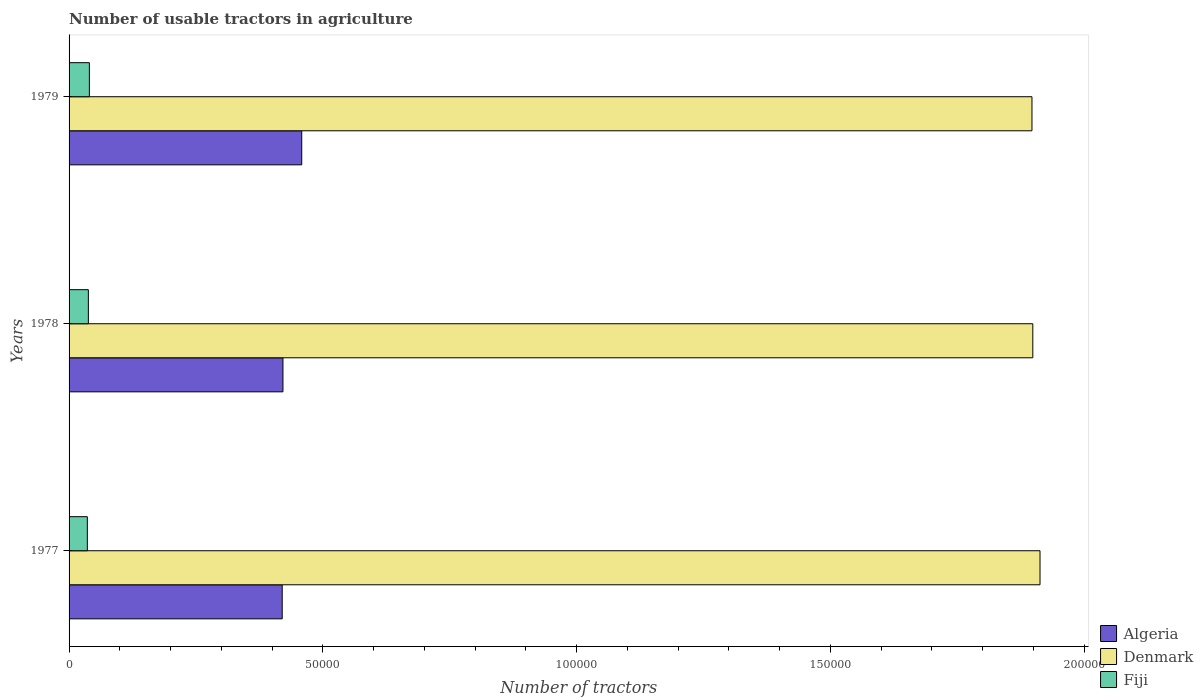How many different coloured bars are there?
Ensure brevity in your answer.  3. Are the number of bars per tick equal to the number of legend labels?
Your answer should be very brief. Yes. How many bars are there on the 1st tick from the bottom?
Offer a terse response. 3. What is the label of the 1st group of bars from the top?
Your response must be concise. 1979. What is the number of usable tractors in agriculture in Fiji in 1977?
Your answer should be compact. 3600. Across all years, what is the maximum number of usable tractors in agriculture in Denmark?
Make the answer very short. 1.91e+05. Across all years, what is the minimum number of usable tractors in agriculture in Fiji?
Your answer should be compact. 3600. What is the total number of usable tractors in agriculture in Algeria in the graph?
Keep it short and to the point. 1.30e+05. What is the difference between the number of usable tractors in agriculture in Denmark in 1977 and that in 1979?
Your response must be concise. 1585. What is the difference between the number of usable tractors in agriculture in Denmark in 1979 and the number of usable tractors in agriculture in Algeria in 1978?
Provide a short and direct response. 1.48e+05. What is the average number of usable tractors in agriculture in Fiji per year?
Your answer should be compact. 3800. In the year 1979, what is the difference between the number of usable tractors in agriculture in Fiji and number of usable tractors in agriculture in Denmark?
Your response must be concise. -1.86e+05. What is the ratio of the number of usable tractors in agriculture in Fiji in 1977 to that in 1978?
Your response must be concise. 0.95. Is the difference between the number of usable tractors in agriculture in Fiji in 1978 and 1979 greater than the difference between the number of usable tractors in agriculture in Denmark in 1978 and 1979?
Your answer should be compact. No. What is the difference between the highest and the second highest number of usable tractors in agriculture in Algeria?
Provide a succinct answer. 3700. What is the difference between the highest and the lowest number of usable tractors in agriculture in Algeria?
Provide a succinct answer. 3847. What does the 3rd bar from the top in 1978 represents?
Offer a terse response. Algeria. What does the 1st bar from the bottom in 1978 represents?
Make the answer very short. Algeria. Is it the case that in every year, the sum of the number of usable tractors in agriculture in Fiji and number of usable tractors in agriculture in Algeria is greater than the number of usable tractors in agriculture in Denmark?
Your answer should be compact. No. Are all the bars in the graph horizontal?
Your response must be concise. Yes. How many years are there in the graph?
Your answer should be compact. 3. What is the difference between two consecutive major ticks on the X-axis?
Your response must be concise. 5.00e+04. Does the graph contain grids?
Make the answer very short. No. How many legend labels are there?
Make the answer very short. 3. How are the legend labels stacked?
Ensure brevity in your answer.  Vertical. What is the title of the graph?
Make the answer very short. Number of usable tractors in agriculture. What is the label or title of the X-axis?
Provide a short and direct response. Number of tractors. What is the label or title of the Y-axis?
Offer a very short reply. Years. What is the Number of tractors of Algeria in 1977?
Give a very brief answer. 4.20e+04. What is the Number of tractors of Denmark in 1977?
Offer a very short reply. 1.91e+05. What is the Number of tractors in Fiji in 1977?
Provide a short and direct response. 3600. What is the Number of tractors in Algeria in 1978?
Provide a short and direct response. 4.21e+04. What is the Number of tractors in Denmark in 1978?
Offer a very short reply. 1.90e+05. What is the Number of tractors in Fiji in 1978?
Keep it short and to the point. 3800. What is the Number of tractors in Algeria in 1979?
Offer a very short reply. 4.58e+04. What is the Number of tractors in Denmark in 1979?
Provide a short and direct response. 1.90e+05. What is the Number of tractors of Fiji in 1979?
Provide a short and direct response. 4000. Across all years, what is the maximum Number of tractors of Algeria?
Your answer should be compact. 4.58e+04. Across all years, what is the maximum Number of tractors in Denmark?
Make the answer very short. 1.91e+05. Across all years, what is the maximum Number of tractors of Fiji?
Offer a very short reply. 4000. Across all years, what is the minimum Number of tractors of Algeria?
Make the answer very short. 4.20e+04. Across all years, what is the minimum Number of tractors of Denmark?
Ensure brevity in your answer.  1.90e+05. Across all years, what is the minimum Number of tractors in Fiji?
Offer a very short reply. 3600. What is the total Number of tractors in Algeria in the graph?
Your answer should be very brief. 1.30e+05. What is the total Number of tractors of Denmark in the graph?
Keep it short and to the point. 5.71e+05. What is the total Number of tractors in Fiji in the graph?
Provide a succinct answer. 1.14e+04. What is the difference between the Number of tractors of Algeria in 1977 and that in 1978?
Make the answer very short. -147. What is the difference between the Number of tractors in Denmark in 1977 and that in 1978?
Offer a very short reply. 1418. What is the difference between the Number of tractors in Fiji in 1977 and that in 1978?
Provide a succinct answer. -200. What is the difference between the Number of tractors of Algeria in 1977 and that in 1979?
Make the answer very short. -3847. What is the difference between the Number of tractors in Denmark in 1977 and that in 1979?
Your answer should be very brief. 1585. What is the difference between the Number of tractors in Fiji in 1977 and that in 1979?
Provide a succinct answer. -400. What is the difference between the Number of tractors in Algeria in 1978 and that in 1979?
Offer a terse response. -3700. What is the difference between the Number of tractors in Denmark in 1978 and that in 1979?
Offer a terse response. 167. What is the difference between the Number of tractors in Fiji in 1978 and that in 1979?
Offer a terse response. -200. What is the difference between the Number of tractors of Algeria in 1977 and the Number of tractors of Denmark in 1978?
Ensure brevity in your answer.  -1.48e+05. What is the difference between the Number of tractors in Algeria in 1977 and the Number of tractors in Fiji in 1978?
Provide a short and direct response. 3.82e+04. What is the difference between the Number of tractors in Denmark in 1977 and the Number of tractors in Fiji in 1978?
Provide a succinct answer. 1.88e+05. What is the difference between the Number of tractors in Algeria in 1977 and the Number of tractors in Denmark in 1979?
Provide a short and direct response. -1.48e+05. What is the difference between the Number of tractors of Algeria in 1977 and the Number of tractors of Fiji in 1979?
Offer a terse response. 3.80e+04. What is the difference between the Number of tractors of Denmark in 1977 and the Number of tractors of Fiji in 1979?
Your answer should be compact. 1.87e+05. What is the difference between the Number of tractors of Algeria in 1978 and the Number of tractors of Denmark in 1979?
Provide a succinct answer. -1.48e+05. What is the difference between the Number of tractors of Algeria in 1978 and the Number of tractors of Fiji in 1979?
Keep it short and to the point. 3.81e+04. What is the difference between the Number of tractors in Denmark in 1978 and the Number of tractors in Fiji in 1979?
Give a very brief answer. 1.86e+05. What is the average Number of tractors of Algeria per year?
Ensure brevity in your answer.  4.33e+04. What is the average Number of tractors in Denmark per year?
Give a very brief answer. 1.90e+05. What is the average Number of tractors of Fiji per year?
Provide a succinct answer. 3800. In the year 1977, what is the difference between the Number of tractors in Algeria and Number of tractors in Denmark?
Your answer should be compact. -1.49e+05. In the year 1977, what is the difference between the Number of tractors in Algeria and Number of tractors in Fiji?
Make the answer very short. 3.84e+04. In the year 1977, what is the difference between the Number of tractors of Denmark and Number of tractors of Fiji?
Make the answer very short. 1.88e+05. In the year 1978, what is the difference between the Number of tractors of Algeria and Number of tractors of Denmark?
Give a very brief answer. -1.48e+05. In the year 1978, what is the difference between the Number of tractors of Algeria and Number of tractors of Fiji?
Your answer should be compact. 3.83e+04. In the year 1978, what is the difference between the Number of tractors in Denmark and Number of tractors in Fiji?
Provide a short and direct response. 1.86e+05. In the year 1979, what is the difference between the Number of tractors in Algeria and Number of tractors in Denmark?
Make the answer very short. -1.44e+05. In the year 1979, what is the difference between the Number of tractors of Algeria and Number of tractors of Fiji?
Offer a terse response. 4.18e+04. In the year 1979, what is the difference between the Number of tractors of Denmark and Number of tractors of Fiji?
Offer a very short reply. 1.86e+05. What is the ratio of the Number of tractors of Denmark in 1977 to that in 1978?
Offer a very short reply. 1.01. What is the ratio of the Number of tractors of Fiji in 1977 to that in 1978?
Offer a very short reply. 0.95. What is the ratio of the Number of tractors in Algeria in 1977 to that in 1979?
Make the answer very short. 0.92. What is the ratio of the Number of tractors of Denmark in 1977 to that in 1979?
Offer a terse response. 1.01. What is the ratio of the Number of tractors in Fiji in 1977 to that in 1979?
Your answer should be very brief. 0.9. What is the ratio of the Number of tractors in Algeria in 1978 to that in 1979?
Provide a succinct answer. 0.92. What is the ratio of the Number of tractors in Denmark in 1978 to that in 1979?
Your response must be concise. 1. What is the ratio of the Number of tractors of Fiji in 1978 to that in 1979?
Offer a terse response. 0.95. What is the difference between the highest and the second highest Number of tractors of Algeria?
Ensure brevity in your answer.  3700. What is the difference between the highest and the second highest Number of tractors in Denmark?
Your answer should be very brief. 1418. What is the difference between the highest and the lowest Number of tractors in Algeria?
Give a very brief answer. 3847. What is the difference between the highest and the lowest Number of tractors of Denmark?
Keep it short and to the point. 1585. What is the difference between the highest and the lowest Number of tractors in Fiji?
Provide a succinct answer. 400. 